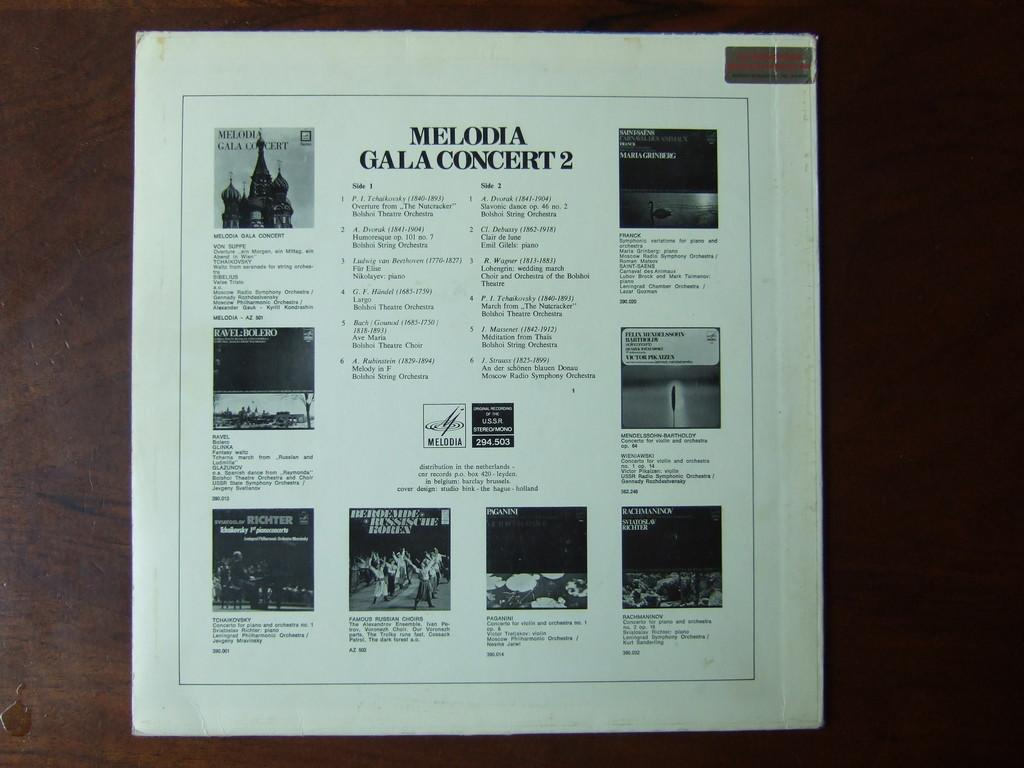<image>
Write a terse but informative summary of the picture. Back of record jacket for Melodia Gala Concert 2 with many other records being advertised. 